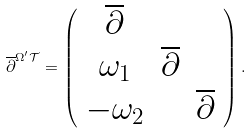Convert formula to latex. <formula><loc_0><loc_0><loc_500><loc_500>\overline { \partial } ^ { \Omega ^ { \prime } \mathcal { T } } = \left ( \begin{array} { c c c } \overline { \partial } & & \\ \omega _ { 1 } & \overline { \partial } & \\ - \omega _ { 2 } & & \overline { \partial } \end{array} \right ) .</formula> 